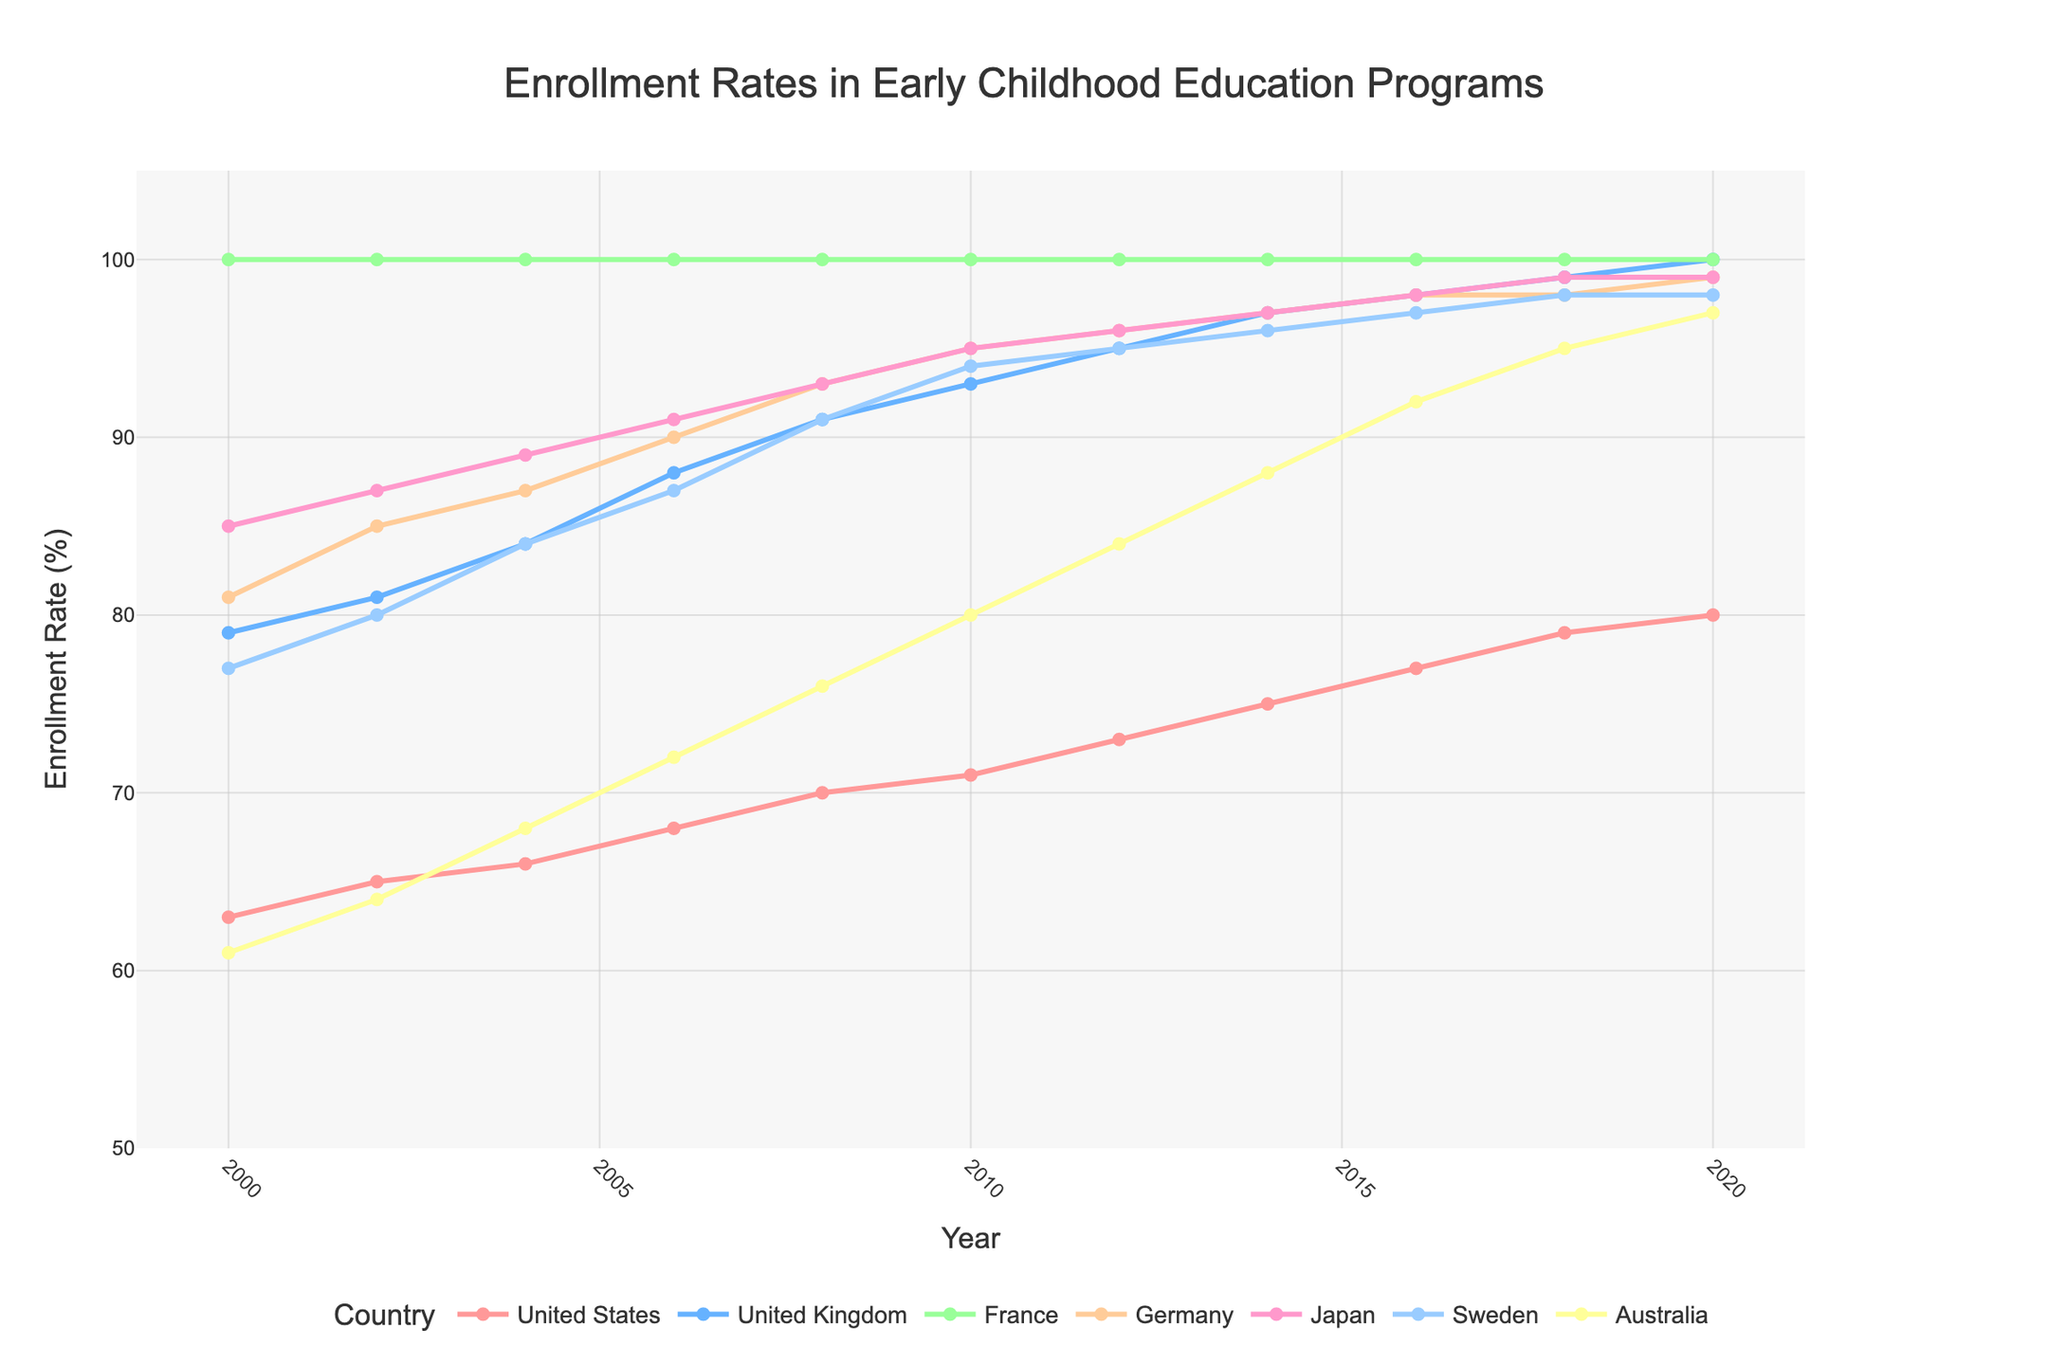Which country shows the highest enrollment rate in 2020? By looking at the data points on the figure for each country, the line for France consistently holds the maximum value through all years including 2020.
Answer: France What is the difference in enrollment rates between Germany and Japan in 2010? Identify the data points for Germany and Japan in the year 2010 from the figure. The enrollment rate for Germany is 95% and for Japan is 95%. Calculate the difference: 95 - 95 = 0.
Answer: 0 Which country has shown a steady increase in enrollment rates from 2000 to 2020 without any decline? Analyze each country's trend line from 2000 to 2020. Only Australia shows a steady increase without any decline.
Answer: Australia How much did the enrollment rate increase in the United States from 2000 to 2010? Find the enrollment rates for the United States in 2000 and 2010. They are 63% and 71%, respectively. Calculate the increase: 71 - 63 = 8.
Answer: 8% Between Japan and Sweden, which country had a higher rate in 2016, and by how much? Locate the rates for Japan and Sweden in 2016. Japan’s rate is 98% and Sweden’s rate is 97%. The difference is 98 - 97 = 1.
Answer: Japan by 1 Which country's enrollment rate stays at 100% throughout the years shown in the figure? By observing the figure, it's clear that France maintains a 100% enrollment rate across all years.
Answer: France What is the average enrollment rate for Sweden over the entire period? Sum up the enrollment rates of Sweden for each listed year (77, 80, 84, 87, 91, 94, 95, 96, 97, 98, 98) and divide by the number of years (11). (77 + 80 + 84 + 87 + 91 + 94 + 95 + 96 + 97 + 98 + 98) / 11 = 898 / 11 = 81.64.
Answer: 81.64% Compare the enrollment rates of the United Kingdom and Australia in 2008. Which country had a higher rate and what was the difference? From the figure, United Kingdom's rate in 2008 is 91% and Australia's rate is 76%. Calculate the difference: 91 - 76 = 15.
Answer: United Kingdom by 15 What is the general trend for Germany’s enrollment rates from 2000 to 2020? Review the trend line for Germany from 2000 to 2020. The enrollment rate in 2000 is 81% and increases steadily to 99% in 2020.
Answer: Increasing Which country shows the most rapid increase in enrollment rate between 2000 and 2018? Compare the slopes of the trend lines between 2000 and 2018 for each country. Australia shows the most rapid increase from 61% to 95%.
Answer: Australia 